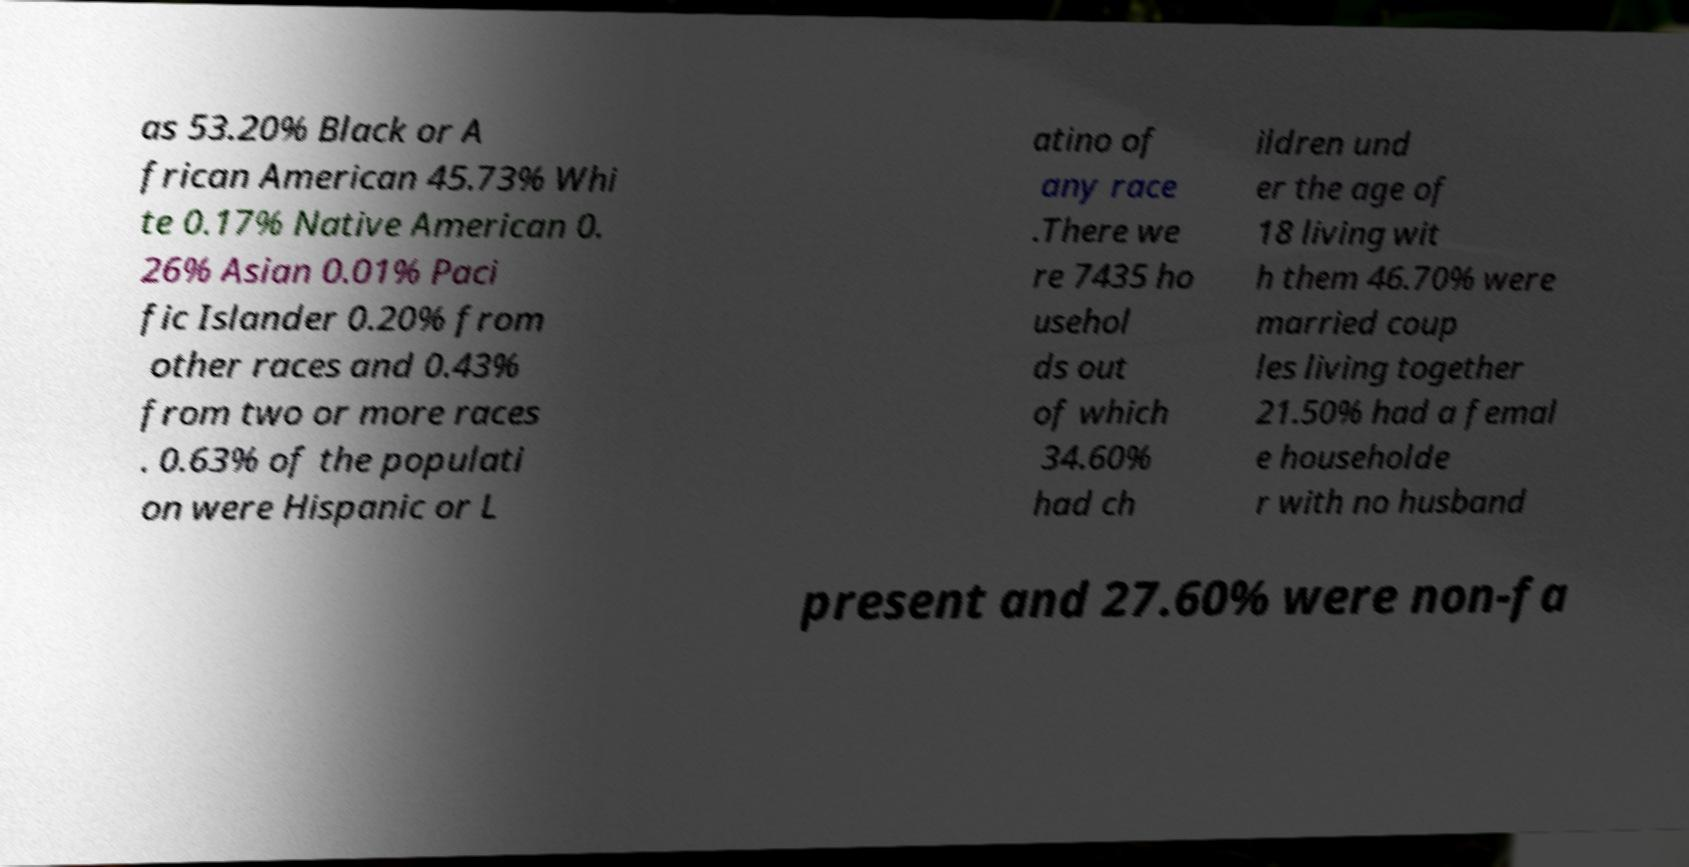For documentation purposes, I need the text within this image transcribed. Could you provide that? as 53.20% Black or A frican American 45.73% Whi te 0.17% Native American 0. 26% Asian 0.01% Paci fic Islander 0.20% from other races and 0.43% from two or more races . 0.63% of the populati on were Hispanic or L atino of any race .There we re 7435 ho usehol ds out of which 34.60% had ch ildren und er the age of 18 living wit h them 46.70% were married coup les living together 21.50% had a femal e householde r with no husband present and 27.60% were non-fa 